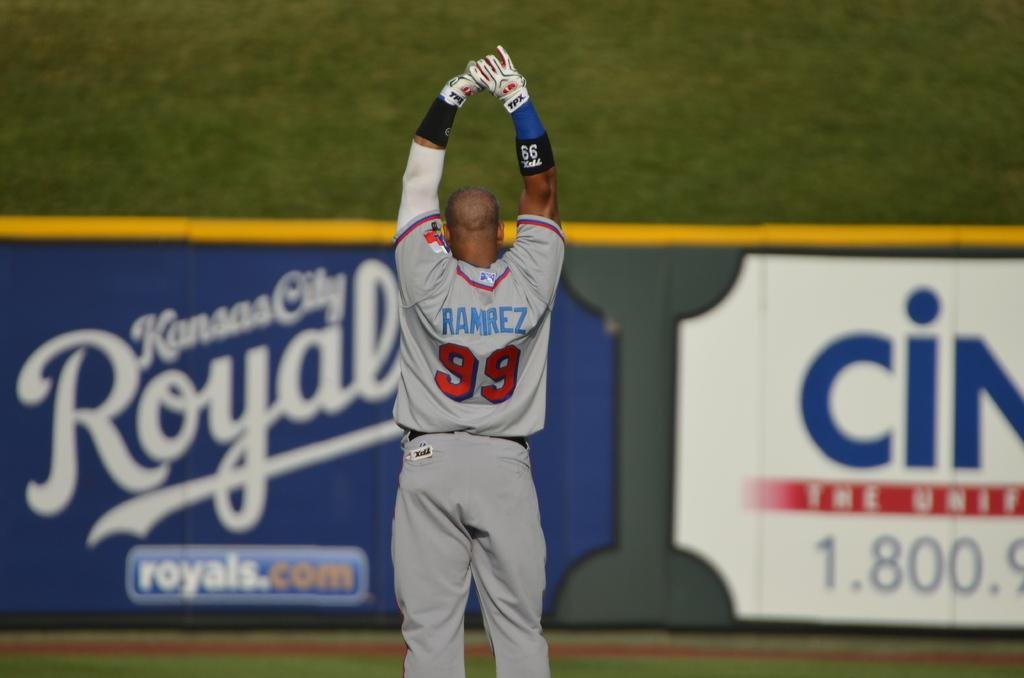<image>
Create a compact narrative representing the image presented. A guy wearing a jersey with the name RAMIREZ and the number 99 on it. 